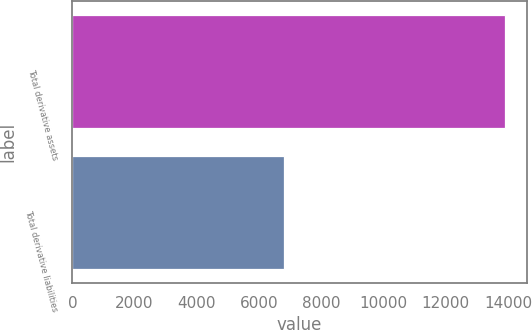Convert chart to OTSL. <chart><loc_0><loc_0><loc_500><loc_500><bar_chart><fcel>Total derivative assets<fcel>Total derivative liabilities<nl><fcel>13903<fcel>6813<nl></chart> 